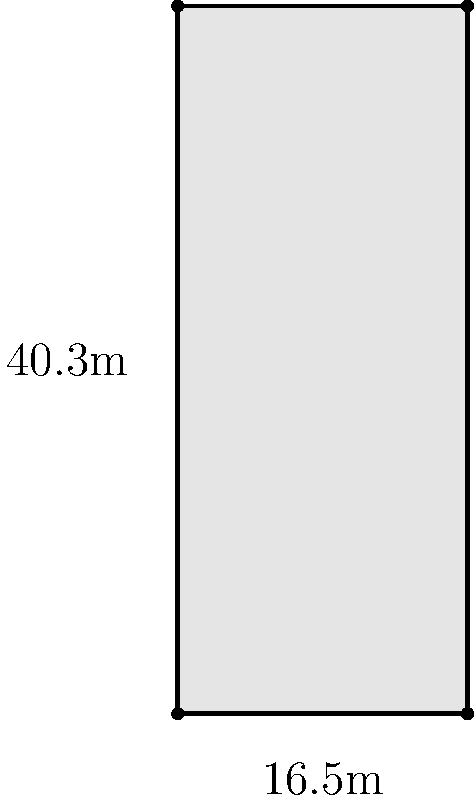As a keen observer of German soccer, you've noticed that the penalty box dimensions are crucial for tactical analysis. Given that the penalty box in a standard Bundesliga pitch measures 16.5 meters wide and 40.3 meters long, what is the total area of the penalty box in square meters? To calculate the area of the penalty box, we need to follow these steps:

1. Identify the shape: The penalty box is a rectangle.

2. Recall the formula for the area of a rectangle:
   Area = length × width

3. Plug in the given dimensions:
   Length = 40.3 meters
   Width = 16.5 meters

4. Calculate the area:
   Area = 40.3 m × 16.5 m
        = 664.95 m²

5. Round to two decimal places for practical use:
   Area ≈ 664.95 m²

This area is crucial for understanding the space defenders must cover and the range strikers have for potential shots on goal, which can significantly impact tactical decisions in German soccer matches.
Answer: 664.95 m² 